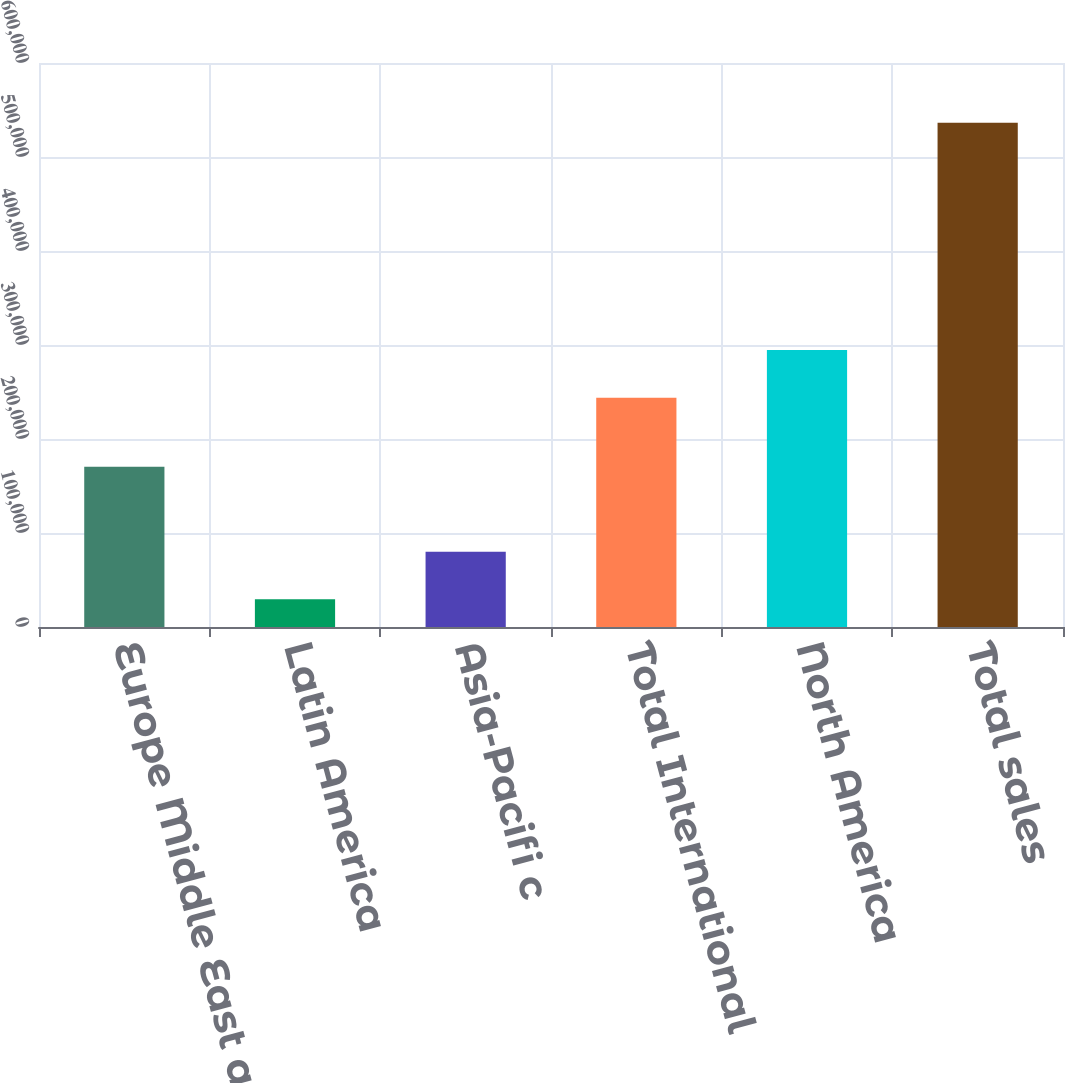Convert chart to OTSL. <chart><loc_0><loc_0><loc_500><loc_500><bar_chart><fcel>Europe Middle East and Africa<fcel>Latin America<fcel>Asia-Pacifi c<fcel>Total International<fcel>North America<fcel>Total sales<nl><fcel>170544<fcel>29406<fcel>80105.1<fcel>243854<fcel>294553<fcel>536397<nl></chart> 